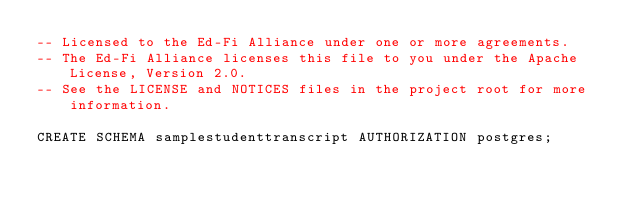Convert code to text. <code><loc_0><loc_0><loc_500><loc_500><_SQL_>-- Licensed to the Ed-Fi Alliance under one or more agreements.
-- The Ed-Fi Alliance licenses this file to you under the Apache License, Version 2.0.
-- See the LICENSE and NOTICES files in the project root for more information.

CREATE SCHEMA samplestudenttranscript AUTHORIZATION postgres;
</code> 